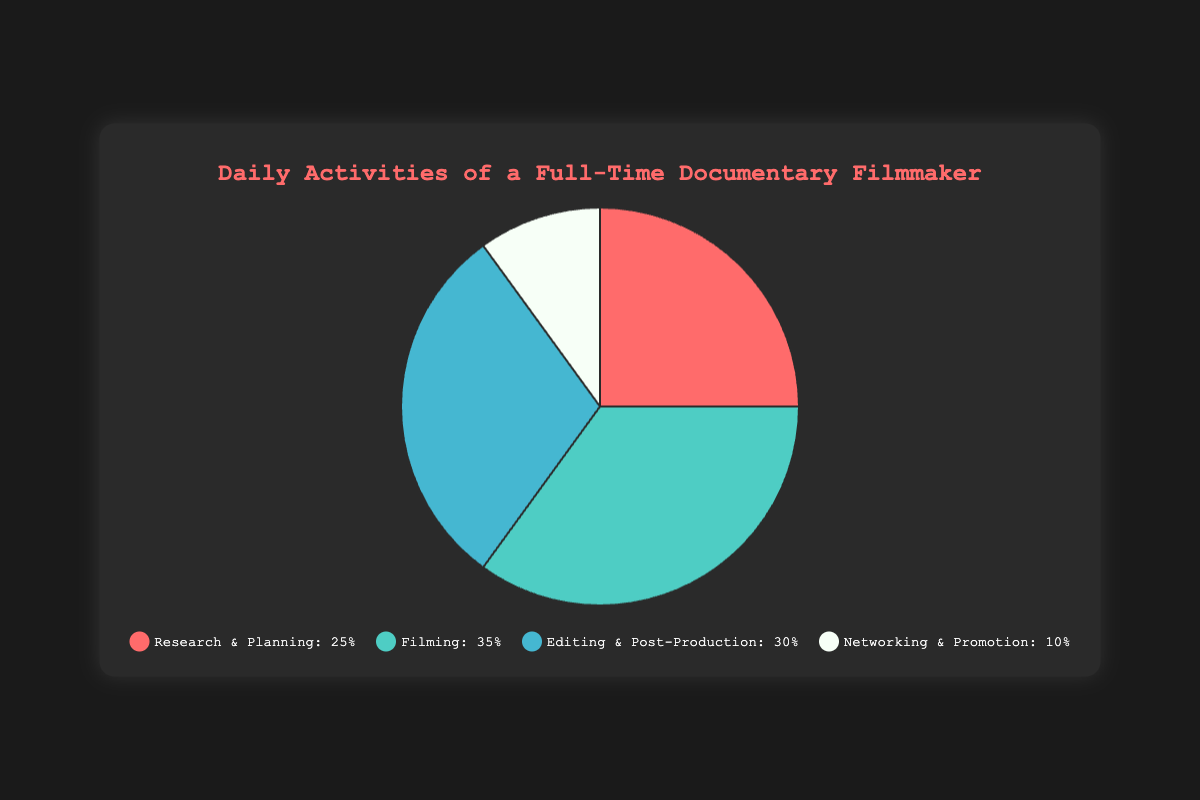What percentage of time does the filmmaker spend on Research & Planning and Networking & Promotion combined? First, find the percentages for Research & Planning and Networking & Promotion which are 25% and 10% respectively. Add them together: 25 + 10 = 35.
Answer: 35% Which activity occupies the largest portion of the filmmaker's day? Look at the percentages of time spent on each activity. Filming has the highest percentage at 35%.
Answer: Filming How does the time spent on Editing & Post-Production compare to the time spent on Research & Planning? Editing & Post-Production takes 30% of the time while Research & Planning takes 25%. Compare the two: 30% > 25%.
Answer: Editing & Post-Production takes more time than Research & Planning If the filmmaker decided to decrease Filming time by 5% and distribute it equally between Research & Planning and Networking & Promotion, what would their new percentages be? Filming decreases from 35% to 30%. The 5% is distributed equally between Research & Planning and Networking & Promotion. Add 2.5% to both: Research & Planning becomes 25 + 2.5 = 27.5% and Networking & Promotion becomes 10 + 2.5 = 12.5%.
Answer: Research & Planning: 27.5%, Networking & Promotion: 12.5% What is the ratio of time spent on Networking & Promotion to time spent on Editing & Post-Production? Networking & Promotion is 10% and Editing & Post-Production is 30%. The ratio is 10:30, which simplifies to 1:3.
Answer: 1:3 Which activity takes the least time in a day? Refer to the percentages for each activity. Networking & Promotion is allocated 10%, which is the smallest percentage.
Answer: Networking & Promotion Imagine the filmmaker wants to spend equal time researching and editing. How much time should be reallocated from Editing & Post-Production to Research & Planning? Currently, Research & Planning is 25% and Editing & Post-Production is 30%. To make them equal, calculate the difference: 30 - 25 = 5%. Reallocate 5% from Editing & Post-Production to Research & Planning.
Answer: 5% How many times more is the percentage of time spent on Filming compared to Networking & Promotion? Filming is 35% and Networking & Promotion is 10%. Divide the percentage of Filming by Networking & Promotion: 35 / 10 = 3.5.
Answer: 3.5 times What visual attribute immediately indicates the largest portion of time spent on Filming? The size of the pie slice representing Filming is visibly the largest among all other activities.
Answer: Largest pie slice If the time spent on Editing & Post-Production is reduced by 10% and added to Networking & Promotion, what are the new percentages? Editing & Post-Production reduces by 10% from 30% to 20%. Add that 10% to Networking & Promotion, which increases from 10% to 20%.
Answer: Editing & Post-Production: 20%, Networking & Promotion: 20% 